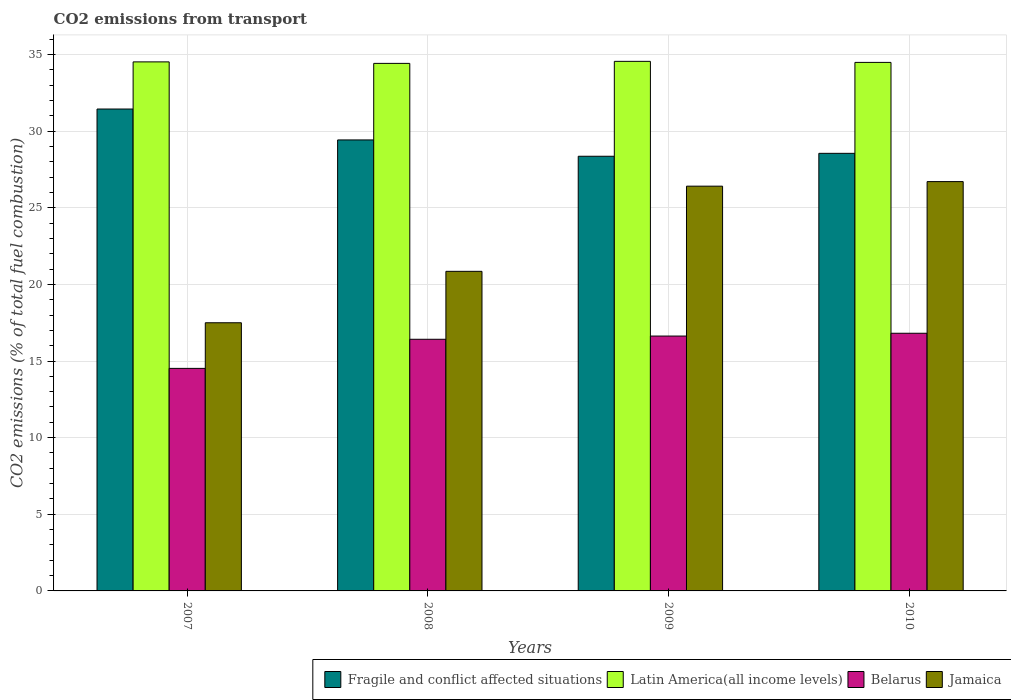How many different coloured bars are there?
Ensure brevity in your answer.  4. How many groups of bars are there?
Provide a succinct answer. 4. Are the number of bars per tick equal to the number of legend labels?
Your answer should be very brief. Yes. How many bars are there on the 3rd tick from the left?
Offer a terse response. 4. How many bars are there on the 4th tick from the right?
Make the answer very short. 4. What is the label of the 3rd group of bars from the left?
Make the answer very short. 2009. What is the total CO2 emitted in Belarus in 2010?
Your answer should be very brief. 16.81. Across all years, what is the maximum total CO2 emitted in Latin America(all income levels)?
Your answer should be very brief. 34.55. Across all years, what is the minimum total CO2 emitted in Belarus?
Offer a terse response. 14.52. In which year was the total CO2 emitted in Latin America(all income levels) minimum?
Make the answer very short. 2008. What is the total total CO2 emitted in Belarus in the graph?
Offer a very short reply. 64.38. What is the difference between the total CO2 emitted in Latin America(all income levels) in 2008 and that in 2009?
Your answer should be very brief. -0.13. What is the difference between the total CO2 emitted in Latin America(all income levels) in 2010 and the total CO2 emitted in Belarus in 2009?
Make the answer very short. 17.85. What is the average total CO2 emitted in Belarus per year?
Your answer should be compact. 16.09. In the year 2010, what is the difference between the total CO2 emitted in Jamaica and total CO2 emitted in Fragile and conflict affected situations?
Ensure brevity in your answer.  -1.84. What is the ratio of the total CO2 emitted in Fragile and conflict affected situations in 2009 to that in 2010?
Provide a short and direct response. 0.99. Is the total CO2 emitted in Belarus in 2007 less than that in 2008?
Provide a short and direct response. Yes. What is the difference between the highest and the second highest total CO2 emitted in Latin America(all income levels)?
Make the answer very short. 0.03. What is the difference between the highest and the lowest total CO2 emitted in Latin America(all income levels)?
Keep it short and to the point. 0.13. Is the sum of the total CO2 emitted in Belarus in 2007 and 2009 greater than the maximum total CO2 emitted in Jamaica across all years?
Offer a very short reply. Yes. Is it the case that in every year, the sum of the total CO2 emitted in Fragile and conflict affected situations and total CO2 emitted in Latin America(all income levels) is greater than the sum of total CO2 emitted in Belarus and total CO2 emitted in Jamaica?
Make the answer very short. Yes. What does the 3rd bar from the left in 2009 represents?
Offer a very short reply. Belarus. What does the 4th bar from the right in 2008 represents?
Make the answer very short. Fragile and conflict affected situations. Is it the case that in every year, the sum of the total CO2 emitted in Belarus and total CO2 emitted in Latin America(all income levels) is greater than the total CO2 emitted in Fragile and conflict affected situations?
Ensure brevity in your answer.  Yes. Are all the bars in the graph horizontal?
Provide a short and direct response. No. Are the values on the major ticks of Y-axis written in scientific E-notation?
Your response must be concise. No. Does the graph contain any zero values?
Give a very brief answer. No. How are the legend labels stacked?
Provide a short and direct response. Horizontal. What is the title of the graph?
Your answer should be compact. CO2 emissions from transport. Does "Denmark" appear as one of the legend labels in the graph?
Ensure brevity in your answer.  No. What is the label or title of the Y-axis?
Your answer should be compact. CO2 emissions (% of total fuel combustion). What is the CO2 emissions (% of total fuel combustion) of Fragile and conflict affected situations in 2007?
Provide a succinct answer. 31.44. What is the CO2 emissions (% of total fuel combustion) in Latin America(all income levels) in 2007?
Your response must be concise. 34.52. What is the CO2 emissions (% of total fuel combustion) of Belarus in 2007?
Provide a short and direct response. 14.52. What is the CO2 emissions (% of total fuel combustion) of Jamaica in 2007?
Offer a very short reply. 17.5. What is the CO2 emissions (% of total fuel combustion) of Fragile and conflict affected situations in 2008?
Ensure brevity in your answer.  29.42. What is the CO2 emissions (% of total fuel combustion) in Latin America(all income levels) in 2008?
Provide a short and direct response. 34.42. What is the CO2 emissions (% of total fuel combustion) in Belarus in 2008?
Your answer should be very brief. 16.42. What is the CO2 emissions (% of total fuel combustion) of Jamaica in 2008?
Your answer should be very brief. 20.85. What is the CO2 emissions (% of total fuel combustion) of Fragile and conflict affected situations in 2009?
Ensure brevity in your answer.  28.36. What is the CO2 emissions (% of total fuel combustion) in Latin America(all income levels) in 2009?
Keep it short and to the point. 34.55. What is the CO2 emissions (% of total fuel combustion) of Belarus in 2009?
Ensure brevity in your answer.  16.63. What is the CO2 emissions (% of total fuel combustion) in Jamaica in 2009?
Your answer should be compact. 26.41. What is the CO2 emissions (% of total fuel combustion) in Fragile and conflict affected situations in 2010?
Your response must be concise. 28.55. What is the CO2 emissions (% of total fuel combustion) of Latin America(all income levels) in 2010?
Ensure brevity in your answer.  34.48. What is the CO2 emissions (% of total fuel combustion) of Belarus in 2010?
Your answer should be compact. 16.81. What is the CO2 emissions (% of total fuel combustion) of Jamaica in 2010?
Keep it short and to the point. 26.71. Across all years, what is the maximum CO2 emissions (% of total fuel combustion) of Fragile and conflict affected situations?
Provide a short and direct response. 31.44. Across all years, what is the maximum CO2 emissions (% of total fuel combustion) in Latin America(all income levels)?
Your response must be concise. 34.55. Across all years, what is the maximum CO2 emissions (% of total fuel combustion) of Belarus?
Your response must be concise. 16.81. Across all years, what is the maximum CO2 emissions (% of total fuel combustion) in Jamaica?
Make the answer very short. 26.71. Across all years, what is the minimum CO2 emissions (% of total fuel combustion) in Fragile and conflict affected situations?
Ensure brevity in your answer.  28.36. Across all years, what is the minimum CO2 emissions (% of total fuel combustion) of Latin America(all income levels)?
Provide a succinct answer. 34.42. Across all years, what is the minimum CO2 emissions (% of total fuel combustion) of Belarus?
Keep it short and to the point. 14.52. Across all years, what is the minimum CO2 emissions (% of total fuel combustion) of Jamaica?
Give a very brief answer. 17.5. What is the total CO2 emissions (% of total fuel combustion) in Fragile and conflict affected situations in the graph?
Offer a very short reply. 117.77. What is the total CO2 emissions (% of total fuel combustion) of Latin America(all income levels) in the graph?
Your answer should be very brief. 137.97. What is the total CO2 emissions (% of total fuel combustion) of Belarus in the graph?
Offer a very short reply. 64.38. What is the total CO2 emissions (% of total fuel combustion) in Jamaica in the graph?
Your response must be concise. 91.46. What is the difference between the CO2 emissions (% of total fuel combustion) of Fragile and conflict affected situations in 2007 and that in 2008?
Keep it short and to the point. 2.02. What is the difference between the CO2 emissions (% of total fuel combustion) of Latin America(all income levels) in 2007 and that in 2008?
Offer a very short reply. 0.1. What is the difference between the CO2 emissions (% of total fuel combustion) of Belarus in 2007 and that in 2008?
Offer a terse response. -1.9. What is the difference between the CO2 emissions (% of total fuel combustion) of Jamaica in 2007 and that in 2008?
Ensure brevity in your answer.  -3.35. What is the difference between the CO2 emissions (% of total fuel combustion) of Fragile and conflict affected situations in 2007 and that in 2009?
Offer a very short reply. 3.08. What is the difference between the CO2 emissions (% of total fuel combustion) in Latin America(all income levels) in 2007 and that in 2009?
Your response must be concise. -0.03. What is the difference between the CO2 emissions (% of total fuel combustion) of Belarus in 2007 and that in 2009?
Ensure brevity in your answer.  -2.11. What is the difference between the CO2 emissions (% of total fuel combustion) of Jamaica in 2007 and that in 2009?
Your answer should be compact. -8.91. What is the difference between the CO2 emissions (% of total fuel combustion) of Fragile and conflict affected situations in 2007 and that in 2010?
Keep it short and to the point. 2.89. What is the difference between the CO2 emissions (% of total fuel combustion) of Latin America(all income levels) in 2007 and that in 2010?
Provide a succinct answer. 0.03. What is the difference between the CO2 emissions (% of total fuel combustion) in Belarus in 2007 and that in 2010?
Offer a very short reply. -2.29. What is the difference between the CO2 emissions (% of total fuel combustion) in Jamaica in 2007 and that in 2010?
Provide a succinct answer. -9.21. What is the difference between the CO2 emissions (% of total fuel combustion) of Fragile and conflict affected situations in 2008 and that in 2009?
Provide a short and direct response. 1.06. What is the difference between the CO2 emissions (% of total fuel combustion) of Latin America(all income levels) in 2008 and that in 2009?
Your answer should be compact. -0.13. What is the difference between the CO2 emissions (% of total fuel combustion) of Belarus in 2008 and that in 2009?
Your answer should be compact. -0.21. What is the difference between the CO2 emissions (% of total fuel combustion) of Jamaica in 2008 and that in 2009?
Your answer should be very brief. -5.56. What is the difference between the CO2 emissions (% of total fuel combustion) in Fragile and conflict affected situations in 2008 and that in 2010?
Ensure brevity in your answer.  0.87. What is the difference between the CO2 emissions (% of total fuel combustion) of Latin America(all income levels) in 2008 and that in 2010?
Ensure brevity in your answer.  -0.06. What is the difference between the CO2 emissions (% of total fuel combustion) in Belarus in 2008 and that in 2010?
Keep it short and to the point. -0.39. What is the difference between the CO2 emissions (% of total fuel combustion) of Jamaica in 2008 and that in 2010?
Keep it short and to the point. -5.85. What is the difference between the CO2 emissions (% of total fuel combustion) in Fragile and conflict affected situations in 2009 and that in 2010?
Give a very brief answer. -0.19. What is the difference between the CO2 emissions (% of total fuel combustion) in Latin America(all income levels) in 2009 and that in 2010?
Provide a succinct answer. 0.07. What is the difference between the CO2 emissions (% of total fuel combustion) in Belarus in 2009 and that in 2010?
Make the answer very short. -0.18. What is the difference between the CO2 emissions (% of total fuel combustion) in Jamaica in 2009 and that in 2010?
Provide a succinct answer. -0.3. What is the difference between the CO2 emissions (% of total fuel combustion) in Fragile and conflict affected situations in 2007 and the CO2 emissions (% of total fuel combustion) in Latin America(all income levels) in 2008?
Make the answer very short. -2.98. What is the difference between the CO2 emissions (% of total fuel combustion) in Fragile and conflict affected situations in 2007 and the CO2 emissions (% of total fuel combustion) in Belarus in 2008?
Ensure brevity in your answer.  15.02. What is the difference between the CO2 emissions (% of total fuel combustion) in Fragile and conflict affected situations in 2007 and the CO2 emissions (% of total fuel combustion) in Jamaica in 2008?
Your answer should be very brief. 10.59. What is the difference between the CO2 emissions (% of total fuel combustion) in Latin America(all income levels) in 2007 and the CO2 emissions (% of total fuel combustion) in Belarus in 2008?
Your answer should be compact. 18.1. What is the difference between the CO2 emissions (% of total fuel combustion) of Latin America(all income levels) in 2007 and the CO2 emissions (% of total fuel combustion) of Jamaica in 2008?
Ensure brevity in your answer.  13.67. What is the difference between the CO2 emissions (% of total fuel combustion) in Belarus in 2007 and the CO2 emissions (% of total fuel combustion) in Jamaica in 2008?
Your response must be concise. -6.33. What is the difference between the CO2 emissions (% of total fuel combustion) in Fragile and conflict affected situations in 2007 and the CO2 emissions (% of total fuel combustion) in Latin America(all income levels) in 2009?
Make the answer very short. -3.11. What is the difference between the CO2 emissions (% of total fuel combustion) of Fragile and conflict affected situations in 2007 and the CO2 emissions (% of total fuel combustion) of Belarus in 2009?
Make the answer very short. 14.81. What is the difference between the CO2 emissions (% of total fuel combustion) of Fragile and conflict affected situations in 2007 and the CO2 emissions (% of total fuel combustion) of Jamaica in 2009?
Keep it short and to the point. 5.03. What is the difference between the CO2 emissions (% of total fuel combustion) of Latin America(all income levels) in 2007 and the CO2 emissions (% of total fuel combustion) of Belarus in 2009?
Give a very brief answer. 17.89. What is the difference between the CO2 emissions (% of total fuel combustion) of Latin America(all income levels) in 2007 and the CO2 emissions (% of total fuel combustion) of Jamaica in 2009?
Your answer should be very brief. 8.11. What is the difference between the CO2 emissions (% of total fuel combustion) of Belarus in 2007 and the CO2 emissions (% of total fuel combustion) of Jamaica in 2009?
Your response must be concise. -11.89. What is the difference between the CO2 emissions (% of total fuel combustion) of Fragile and conflict affected situations in 2007 and the CO2 emissions (% of total fuel combustion) of Latin America(all income levels) in 2010?
Offer a very short reply. -3.04. What is the difference between the CO2 emissions (% of total fuel combustion) in Fragile and conflict affected situations in 2007 and the CO2 emissions (% of total fuel combustion) in Belarus in 2010?
Make the answer very short. 14.63. What is the difference between the CO2 emissions (% of total fuel combustion) of Fragile and conflict affected situations in 2007 and the CO2 emissions (% of total fuel combustion) of Jamaica in 2010?
Make the answer very short. 4.74. What is the difference between the CO2 emissions (% of total fuel combustion) in Latin America(all income levels) in 2007 and the CO2 emissions (% of total fuel combustion) in Belarus in 2010?
Make the answer very short. 17.71. What is the difference between the CO2 emissions (% of total fuel combustion) in Latin America(all income levels) in 2007 and the CO2 emissions (% of total fuel combustion) in Jamaica in 2010?
Your response must be concise. 7.81. What is the difference between the CO2 emissions (% of total fuel combustion) of Belarus in 2007 and the CO2 emissions (% of total fuel combustion) of Jamaica in 2010?
Your response must be concise. -12.19. What is the difference between the CO2 emissions (% of total fuel combustion) of Fragile and conflict affected situations in 2008 and the CO2 emissions (% of total fuel combustion) of Latin America(all income levels) in 2009?
Your answer should be very brief. -5.13. What is the difference between the CO2 emissions (% of total fuel combustion) of Fragile and conflict affected situations in 2008 and the CO2 emissions (% of total fuel combustion) of Belarus in 2009?
Provide a short and direct response. 12.8. What is the difference between the CO2 emissions (% of total fuel combustion) of Fragile and conflict affected situations in 2008 and the CO2 emissions (% of total fuel combustion) of Jamaica in 2009?
Give a very brief answer. 3.02. What is the difference between the CO2 emissions (% of total fuel combustion) of Latin America(all income levels) in 2008 and the CO2 emissions (% of total fuel combustion) of Belarus in 2009?
Make the answer very short. 17.79. What is the difference between the CO2 emissions (% of total fuel combustion) of Latin America(all income levels) in 2008 and the CO2 emissions (% of total fuel combustion) of Jamaica in 2009?
Make the answer very short. 8.01. What is the difference between the CO2 emissions (% of total fuel combustion) in Belarus in 2008 and the CO2 emissions (% of total fuel combustion) in Jamaica in 2009?
Your response must be concise. -9.99. What is the difference between the CO2 emissions (% of total fuel combustion) in Fragile and conflict affected situations in 2008 and the CO2 emissions (% of total fuel combustion) in Latin America(all income levels) in 2010?
Ensure brevity in your answer.  -5.06. What is the difference between the CO2 emissions (% of total fuel combustion) in Fragile and conflict affected situations in 2008 and the CO2 emissions (% of total fuel combustion) in Belarus in 2010?
Provide a short and direct response. 12.61. What is the difference between the CO2 emissions (% of total fuel combustion) in Fragile and conflict affected situations in 2008 and the CO2 emissions (% of total fuel combustion) in Jamaica in 2010?
Your answer should be compact. 2.72. What is the difference between the CO2 emissions (% of total fuel combustion) in Latin America(all income levels) in 2008 and the CO2 emissions (% of total fuel combustion) in Belarus in 2010?
Your answer should be very brief. 17.61. What is the difference between the CO2 emissions (% of total fuel combustion) in Latin America(all income levels) in 2008 and the CO2 emissions (% of total fuel combustion) in Jamaica in 2010?
Offer a terse response. 7.71. What is the difference between the CO2 emissions (% of total fuel combustion) in Belarus in 2008 and the CO2 emissions (% of total fuel combustion) in Jamaica in 2010?
Give a very brief answer. -10.29. What is the difference between the CO2 emissions (% of total fuel combustion) of Fragile and conflict affected situations in 2009 and the CO2 emissions (% of total fuel combustion) of Latin America(all income levels) in 2010?
Your answer should be very brief. -6.12. What is the difference between the CO2 emissions (% of total fuel combustion) of Fragile and conflict affected situations in 2009 and the CO2 emissions (% of total fuel combustion) of Belarus in 2010?
Offer a terse response. 11.55. What is the difference between the CO2 emissions (% of total fuel combustion) of Fragile and conflict affected situations in 2009 and the CO2 emissions (% of total fuel combustion) of Jamaica in 2010?
Give a very brief answer. 1.65. What is the difference between the CO2 emissions (% of total fuel combustion) of Latin America(all income levels) in 2009 and the CO2 emissions (% of total fuel combustion) of Belarus in 2010?
Give a very brief answer. 17.74. What is the difference between the CO2 emissions (% of total fuel combustion) in Latin America(all income levels) in 2009 and the CO2 emissions (% of total fuel combustion) in Jamaica in 2010?
Your answer should be very brief. 7.85. What is the difference between the CO2 emissions (% of total fuel combustion) in Belarus in 2009 and the CO2 emissions (% of total fuel combustion) in Jamaica in 2010?
Make the answer very short. -10.08. What is the average CO2 emissions (% of total fuel combustion) in Fragile and conflict affected situations per year?
Ensure brevity in your answer.  29.44. What is the average CO2 emissions (% of total fuel combustion) in Latin America(all income levels) per year?
Ensure brevity in your answer.  34.49. What is the average CO2 emissions (% of total fuel combustion) of Belarus per year?
Make the answer very short. 16.09. What is the average CO2 emissions (% of total fuel combustion) in Jamaica per year?
Provide a succinct answer. 22.86. In the year 2007, what is the difference between the CO2 emissions (% of total fuel combustion) of Fragile and conflict affected situations and CO2 emissions (% of total fuel combustion) of Latin America(all income levels)?
Provide a short and direct response. -3.08. In the year 2007, what is the difference between the CO2 emissions (% of total fuel combustion) in Fragile and conflict affected situations and CO2 emissions (% of total fuel combustion) in Belarus?
Keep it short and to the point. 16.92. In the year 2007, what is the difference between the CO2 emissions (% of total fuel combustion) in Fragile and conflict affected situations and CO2 emissions (% of total fuel combustion) in Jamaica?
Offer a very short reply. 13.95. In the year 2007, what is the difference between the CO2 emissions (% of total fuel combustion) in Latin America(all income levels) and CO2 emissions (% of total fuel combustion) in Belarus?
Give a very brief answer. 20. In the year 2007, what is the difference between the CO2 emissions (% of total fuel combustion) in Latin America(all income levels) and CO2 emissions (% of total fuel combustion) in Jamaica?
Make the answer very short. 17.02. In the year 2007, what is the difference between the CO2 emissions (% of total fuel combustion) of Belarus and CO2 emissions (% of total fuel combustion) of Jamaica?
Provide a succinct answer. -2.98. In the year 2008, what is the difference between the CO2 emissions (% of total fuel combustion) in Fragile and conflict affected situations and CO2 emissions (% of total fuel combustion) in Latin America(all income levels)?
Offer a very short reply. -4.99. In the year 2008, what is the difference between the CO2 emissions (% of total fuel combustion) of Fragile and conflict affected situations and CO2 emissions (% of total fuel combustion) of Belarus?
Give a very brief answer. 13.01. In the year 2008, what is the difference between the CO2 emissions (% of total fuel combustion) in Fragile and conflict affected situations and CO2 emissions (% of total fuel combustion) in Jamaica?
Provide a short and direct response. 8.57. In the year 2008, what is the difference between the CO2 emissions (% of total fuel combustion) of Latin America(all income levels) and CO2 emissions (% of total fuel combustion) of Belarus?
Offer a very short reply. 18. In the year 2008, what is the difference between the CO2 emissions (% of total fuel combustion) in Latin America(all income levels) and CO2 emissions (% of total fuel combustion) in Jamaica?
Give a very brief answer. 13.57. In the year 2008, what is the difference between the CO2 emissions (% of total fuel combustion) of Belarus and CO2 emissions (% of total fuel combustion) of Jamaica?
Offer a very short reply. -4.43. In the year 2009, what is the difference between the CO2 emissions (% of total fuel combustion) of Fragile and conflict affected situations and CO2 emissions (% of total fuel combustion) of Latin America(all income levels)?
Offer a very short reply. -6.19. In the year 2009, what is the difference between the CO2 emissions (% of total fuel combustion) of Fragile and conflict affected situations and CO2 emissions (% of total fuel combustion) of Belarus?
Give a very brief answer. 11.73. In the year 2009, what is the difference between the CO2 emissions (% of total fuel combustion) of Fragile and conflict affected situations and CO2 emissions (% of total fuel combustion) of Jamaica?
Offer a terse response. 1.95. In the year 2009, what is the difference between the CO2 emissions (% of total fuel combustion) of Latin America(all income levels) and CO2 emissions (% of total fuel combustion) of Belarus?
Your answer should be compact. 17.92. In the year 2009, what is the difference between the CO2 emissions (% of total fuel combustion) in Latin America(all income levels) and CO2 emissions (% of total fuel combustion) in Jamaica?
Your response must be concise. 8.14. In the year 2009, what is the difference between the CO2 emissions (% of total fuel combustion) in Belarus and CO2 emissions (% of total fuel combustion) in Jamaica?
Your answer should be compact. -9.78. In the year 2010, what is the difference between the CO2 emissions (% of total fuel combustion) of Fragile and conflict affected situations and CO2 emissions (% of total fuel combustion) of Latin America(all income levels)?
Provide a short and direct response. -5.93. In the year 2010, what is the difference between the CO2 emissions (% of total fuel combustion) of Fragile and conflict affected situations and CO2 emissions (% of total fuel combustion) of Belarus?
Your answer should be very brief. 11.74. In the year 2010, what is the difference between the CO2 emissions (% of total fuel combustion) of Fragile and conflict affected situations and CO2 emissions (% of total fuel combustion) of Jamaica?
Your response must be concise. 1.84. In the year 2010, what is the difference between the CO2 emissions (% of total fuel combustion) in Latin America(all income levels) and CO2 emissions (% of total fuel combustion) in Belarus?
Offer a terse response. 17.67. In the year 2010, what is the difference between the CO2 emissions (% of total fuel combustion) in Latin America(all income levels) and CO2 emissions (% of total fuel combustion) in Jamaica?
Your response must be concise. 7.78. In the year 2010, what is the difference between the CO2 emissions (% of total fuel combustion) in Belarus and CO2 emissions (% of total fuel combustion) in Jamaica?
Offer a terse response. -9.89. What is the ratio of the CO2 emissions (% of total fuel combustion) in Fragile and conflict affected situations in 2007 to that in 2008?
Provide a short and direct response. 1.07. What is the ratio of the CO2 emissions (% of total fuel combustion) of Latin America(all income levels) in 2007 to that in 2008?
Provide a succinct answer. 1. What is the ratio of the CO2 emissions (% of total fuel combustion) in Belarus in 2007 to that in 2008?
Offer a very short reply. 0.88. What is the ratio of the CO2 emissions (% of total fuel combustion) in Jamaica in 2007 to that in 2008?
Offer a terse response. 0.84. What is the ratio of the CO2 emissions (% of total fuel combustion) in Fragile and conflict affected situations in 2007 to that in 2009?
Ensure brevity in your answer.  1.11. What is the ratio of the CO2 emissions (% of total fuel combustion) in Latin America(all income levels) in 2007 to that in 2009?
Your answer should be very brief. 1. What is the ratio of the CO2 emissions (% of total fuel combustion) in Belarus in 2007 to that in 2009?
Make the answer very short. 0.87. What is the ratio of the CO2 emissions (% of total fuel combustion) in Jamaica in 2007 to that in 2009?
Offer a very short reply. 0.66. What is the ratio of the CO2 emissions (% of total fuel combustion) in Fragile and conflict affected situations in 2007 to that in 2010?
Provide a succinct answer. 1.1. What is the ratio of the CO2 emissions (% of total fuel combustion) in Latin America(all income levels) in 2007 to that in 2010?
Give a very brief answer. 1. What is the ratio of the CO2 emissions (% of total fuel combustion) in Belarus in 2007 to that in 2010?
Ensure brevity in your answer.  0.86. What is the ratio of the CO2 emissions (% of total fuel combustion) in Jamaica in 2007 to that in 2010?
Provide a short and direct response. 0.66. What is the ratio of the CO2 emissions (% of total fuel combustion) of Fragile and conflict affected situations in 2008 to that in 2009?
Offer a terse response. 1.04. What is the ratio of the CO2 emissions (% of total fuel combustion) in Latin America(all income levels) in 2008 to that in 2009?
Offer a terse response. 1. What is the ratio of the CO2 emissions (% of total fuel combustion) of Belarus in 2008 to that in 2009?
Ensure brevity in your answer.  0.99. What is the ratio of the CO2 emissions (% of total fuel combustion) in Jamaica in 2008 to that in 2009?
Your response must be concise. 0.79. What is the ratio of the CO2 emissions (% of total fuel combustion) in Fragile and conflict affected situations in 2008 to that in 2010?
Offer a terse response. 1.03. What is the ratio of the CO2 emissions (% of total fuel combustion) in Latin America(all income levels) in 2008 to that in 2010?
Offer a terse response. 1. What is the ratio of the CO2 emissions (% of total fuel combustion) in Belarus in 2008 to that in 2010?
Ensure brevity in your answer.  0.98. What is the ratio of the CO2 emissions (% of total fuel combustion) in Jamaica in 2008 to that in 2010?
Offer a terse response. 0.78. What is the ratio of the CO2 emissions (% of total fuel combustion) of Latin America(all income levels) in 2009 to that in 2010?
Give a very brief answer. 1. What is the difference between the highest and the second highest CO2 emissions (% of total fuel combustion) in Fragile and conflict affected situations?
Your answer should be compact. 2.02. What is the difference between the highest and the second highest CO2 emissions (% of total fuel combustion) in Latin America(all income levels)?
Offer a terse response. 0.03. What is the difference between the highest and the second highest CO2 emissions (% of total fuel combustion) of Belarus?
Make the answer very short. 0.18. What is the difference between the highest and the second highest CO2 emissions (% of total fuel combustion) of Jamaica?
Your answer should be compact. 0.3. What is the difference between the highest and the lowest CO2 emissions (% of total fuel combustion) in Fragile and conflict affected situations?
Provide a short and direct response. 3.08. What is the difference between the highest and the lowest CO2 emissions (% of total fuel combustion) in Latin America(all income levels)?
Your answer should be very brief. 0.13. What is the difference between the highest and the lowest CO2 emissions (% of total fuel combustion) of Belarus?
Keep it short and to the point. 2.29. What is the difference between the highest and the lowest CO2 emissions (% of total fuel combustion) of Jamaica?
Provide a short and direct response. 9.21. 